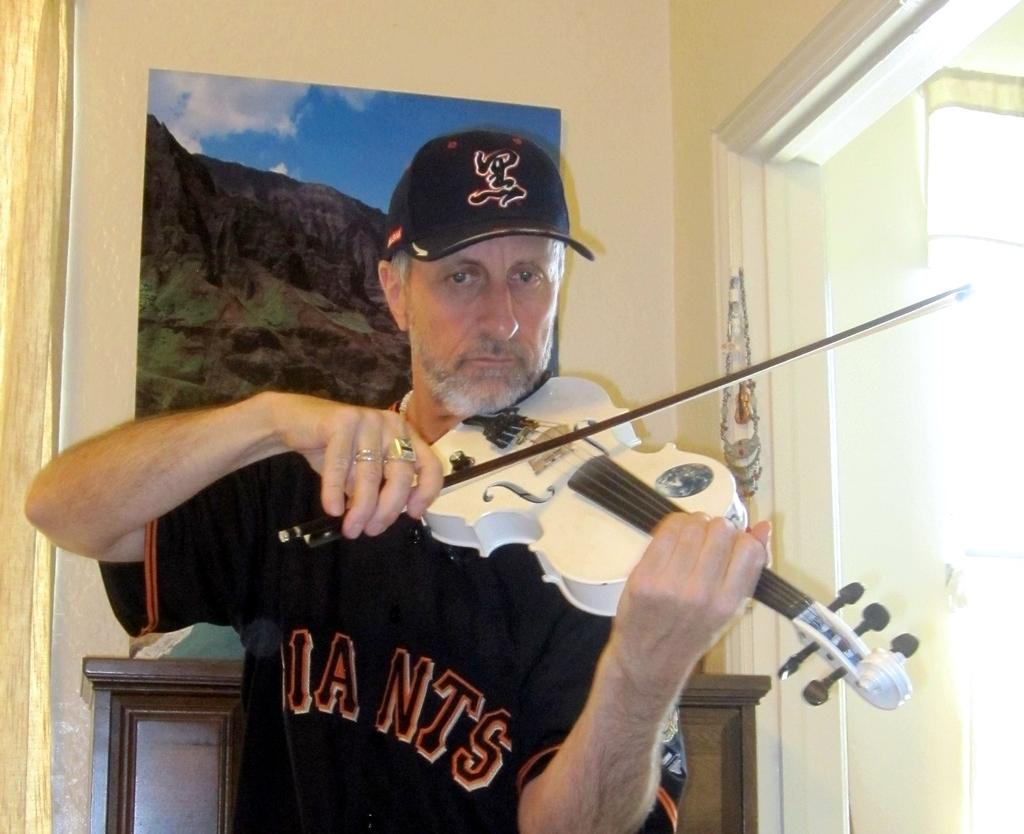What is the main subject of the image? There is a person in the image. What is the person doing in the image? The person is holding a musical instrument. What can be seen in the background of the image? There is a wall and a frame in the background of the image. What news is being reported on the finger in the image? There is no finger or news report present in the image. What type of winter clothing is the person wearing in the image? There is no winter clothing or reference to winter in the image. 